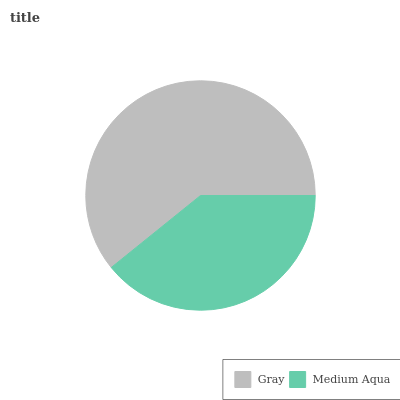Is Medium Aqua the minimum?
Answer yes or no. Yes. Is Gray the maximum?
Answer yes or no. Yes. Is Medium Aqua the maximum?
Answer yes or no. No. Is Gray greater than Medium Aqua?
Answer yes or no. Yes. Is Medium Aqua less than Gray?
Answer yes or no. Yes. Is Medium Aqua greater than Gray?
Answer yes or no. No. Is Gray less than Medium Aqua?
Answer yes or no. No. Is Gray the high median?
Answer yes or no. Yes. Is Medium Aqua the low median?
Answer yes or no. Yes. Is Medium Aqua the high median?
Answer yes or no. No. Is Gray the low median?
Answer yes or no. No. 